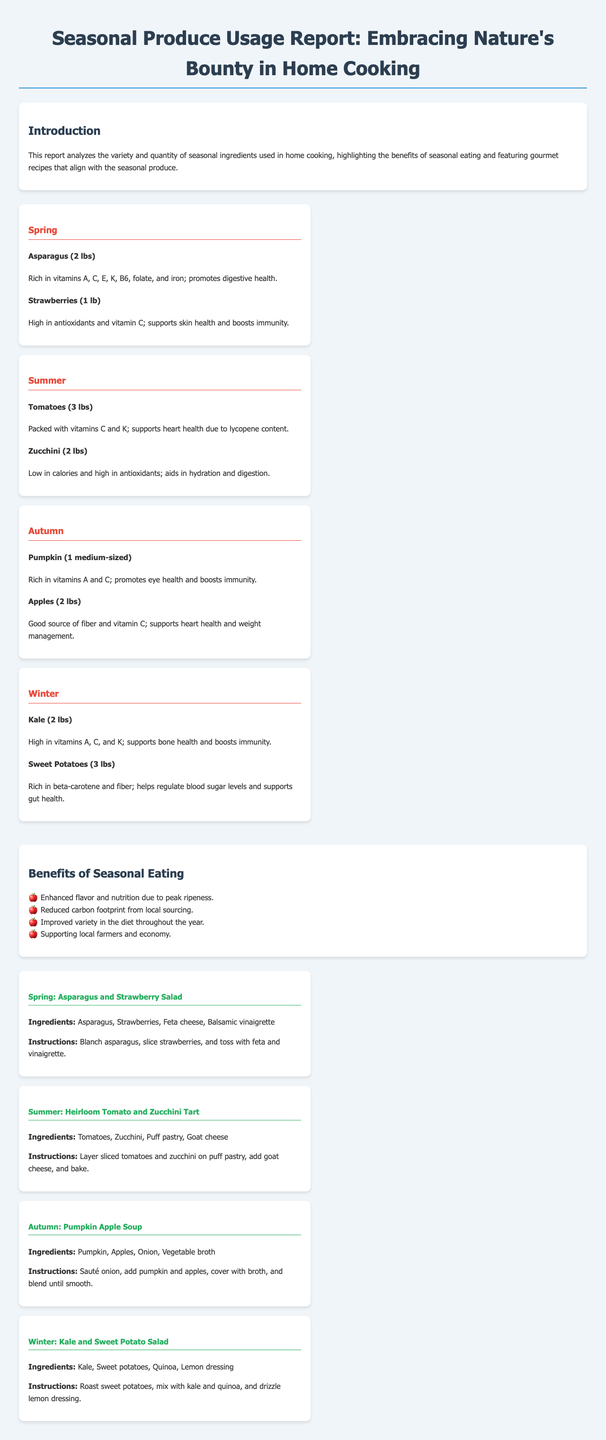What vegetables are featured in Spring? The Spring section lists Asparagus and Strawberries as featured seasonal ingredients.
Answer: Asparagus, Strawberries How many pounds of Tomatoes are used in Summer? The Summer section specifies that 3 lbs of Tomatoes are used in home cooking.
Answer: 3 lbs What is a benefit of eating seasonal produce? The document highlights four benefits, including enhanced flavor and nutrition due to peak ripeness.
Answer: Enhanced flavor and nutrition What is the main ingredient in the Autumn recipe? The Autumn recipe features Pumpkin and Apples as its main ingredients.
Answer: Pumpkin, Apples How many ingredients are listed for the Winter recipe? The Winter recipe includes four ingredients: Kale, Sweet potatoes, Quinoa, Lemon dressing.
Answer: 4 What season features Sweet Potatoes? The Winter section contains the information about Sweet Potatoes being a seasonal ingredient.
Answer: Winter What type of dish is the Summer recipe? The Summer recipe is categorized as a tart, which uses layered ingredients in puff pastry.
Answer: Tart Which fruit is featured in both Spring and Autumn recipes? Both the Spring and Autumn sections feature Strawberry and Apple, respectively.
Answer: None How many recipes are featured in this report? The report showcases a total of four recipes for each season.
Answer: 4 